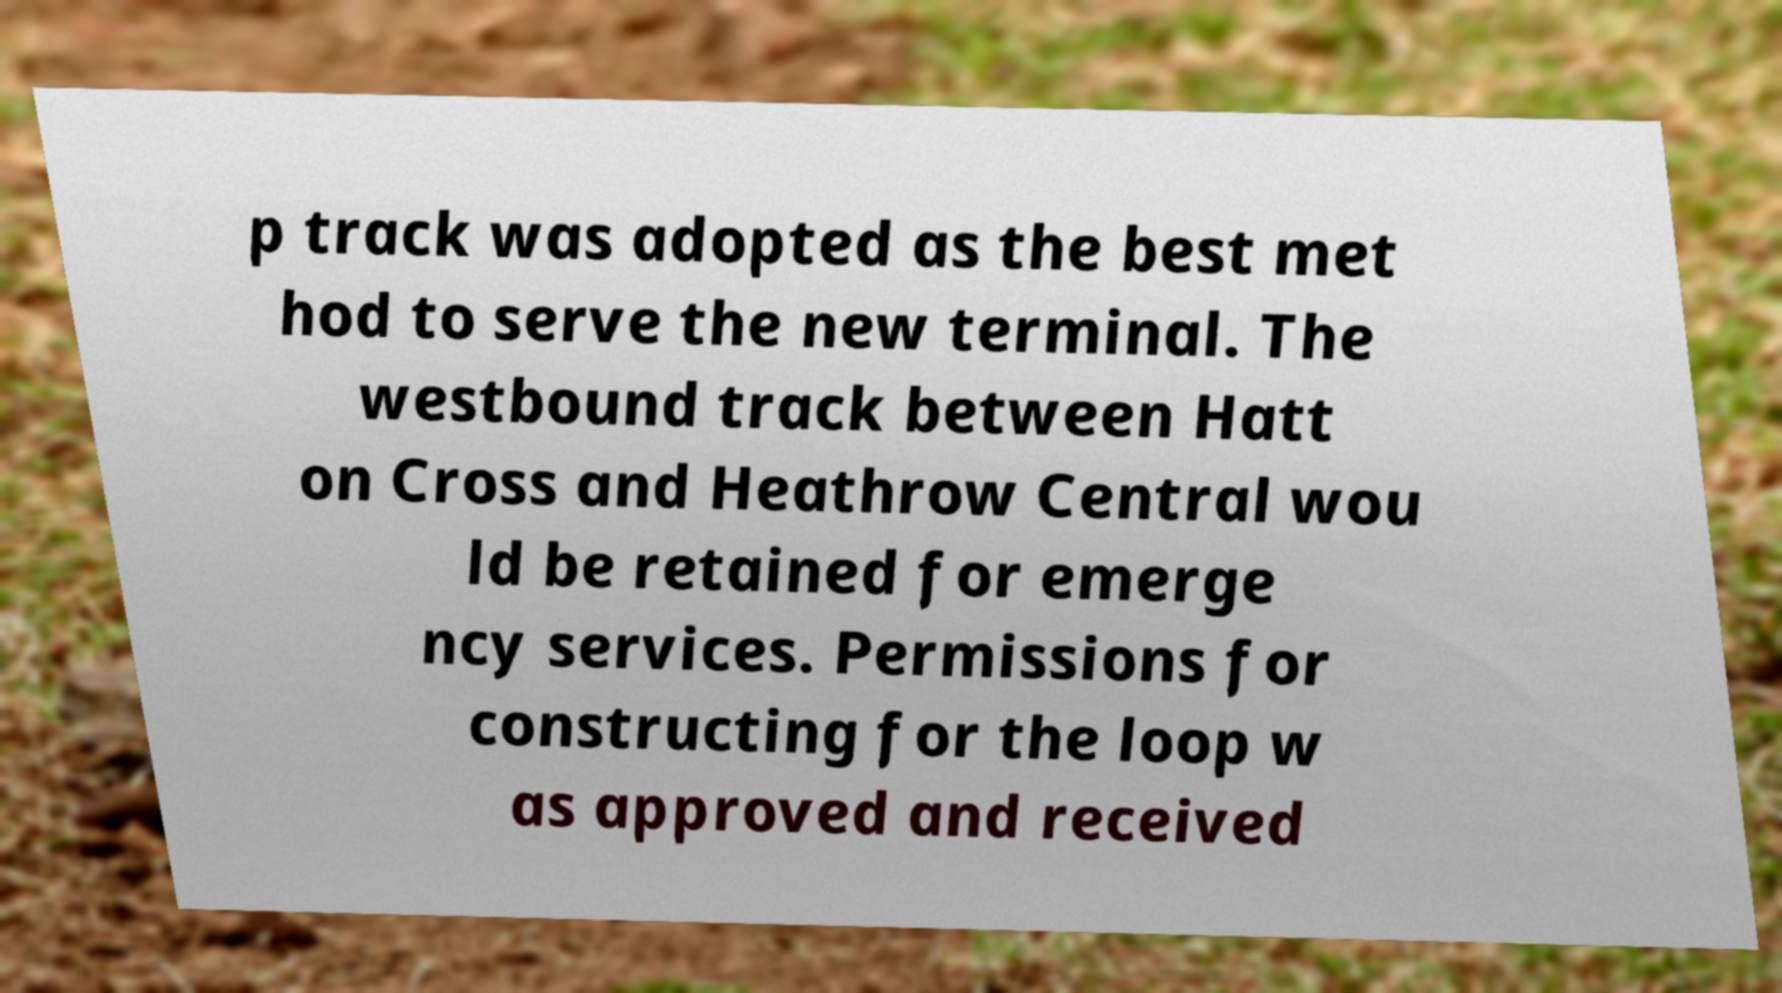What messages or text are displayed in this image? I need them in a readable, typed format. p track was adopted as the best met hod to serve the new terminal. The westbound track between Hatt on Cross and Heathrow Central wou ld be retained for emerge ncy services. Permissions for constructing for the loop w as approved and received 